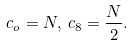Convert formula to latex. <formula><loc_0><loc_0><loc_500><loc_500>c _ { o } = N , \, c _ { 8 } = \frac { N } { 2 } .</formula> 